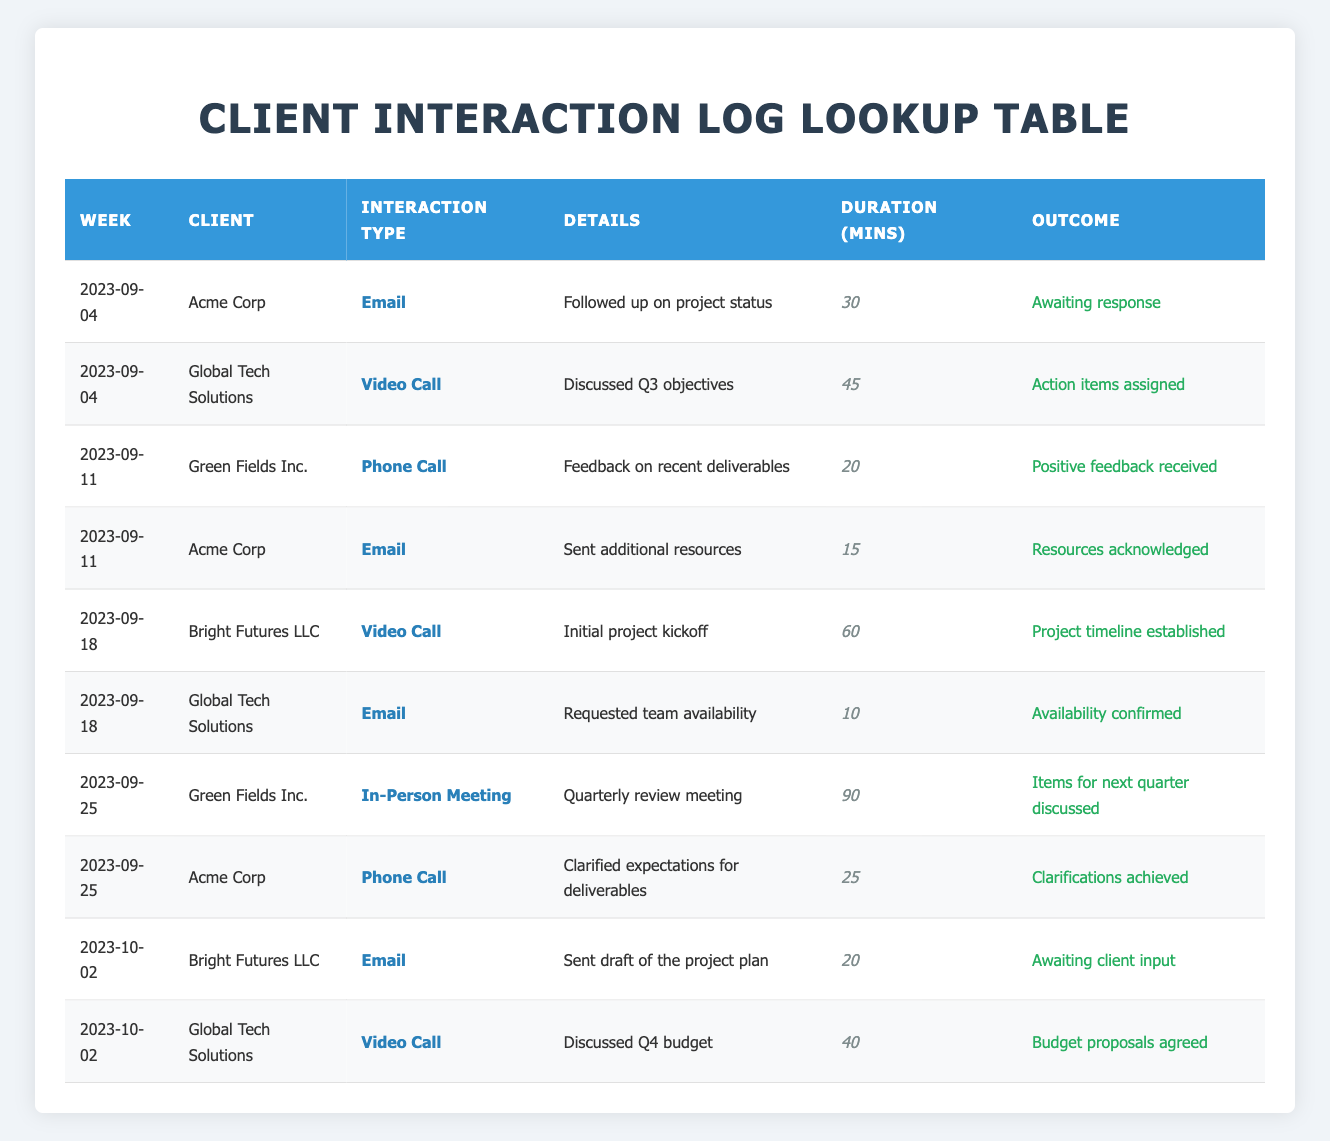What was the interaction type for Acme Corp in the week of 2023-09-04? The interaction type listed for Acme Corp under the week 2023-09-04 is "Email," as seen in the corresponding row of the table.
Answer: Email How many minutes did the video call with Global Tech Solutions take place on 2023-09-04? According to the entry for Global Tech Solutions on the date of 2023-09-04, the duration of the video call was 45 minutes.
Answer: 45 What was the outcome of the interaction with Green Fields Inc. on 2023-09-11? The interaction with Green Fields Inc. on 2023-09-11 resulted in "Positive feedback received," as indicated in the details of the table.
Answer: Positive feedback received What is the total duration of interactions recorded for Bright Futures LLC across all weeks? The interactions for Bright Futures LLC are in the weeks of 2023-09-18 and 2023-10-02. The durations are 60 minutes and 20 minutes respectively. Adding these together gives a total of 60 + 20 = 80 minutes.
Answer: 80 Did any client interaction on 2023-09-18 have a negative outcome? Reviewing the entries for 2023-09-18, both outcomes for Bright Futures LLC and Global Tech Solutions were positive or neutral, indicating no negative outcomes were reported.
Answer: No What was the average duration of client interactions for Acme Corp? There are three interactions for Acme Corp with durations of 30, 15, and 25 minutes. The total duration is 30 + 15 + 25 = 70 minutes. Dividing this by the number of interactions (3), the average is 70/3 ≈ 23.33 minutes.
Answer: Approximately 23.33 Which client had the longest interaction in terms of duration? The longest interaction listed is the in-person meeting with Green Fields Inc. on 2023-09-25, which lasted for 90 minutes.
Answer: Green Fields Inc How many different clients were interacted with in the week of 2023-09-25? The entries for the week of 2023-09-25 show interactions with two clients: Green Fields Inc. and Acme Corp. This indicates that there were two different clients interacted with that week.
Answer: 2 Was there any instance of in-person meetings for clients listed? The log shows that there was one instance of an in-person meeting listed for Green Fields Inc. on 2023-09-25, confirming that such an interaction occurred.
Answer: Yes 